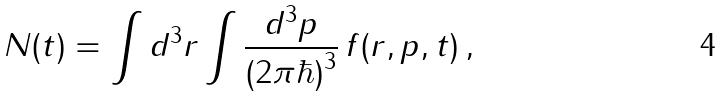<formula> <loc_0><loc_0><loc_500><loc_500>N ( t ) = \int d ^ { 3 } r \int \frac { d ^ { 3 } p } { ( 2 \pi \hbar { ) } ^ { 3 } } \, f ( { r } , { p } , t ) \, ,</formula> 